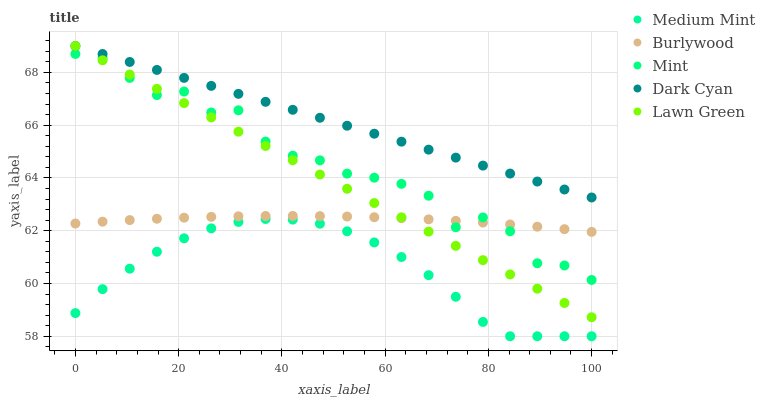Does Medium Mint have the minimum area under the curve?
Answer yes or no. Yes. Does Dark Cyan have the maximum area under the curve?
Answer yes or no. Yes. Does Burlywood have the minimum area under the curve?
Answer yes or no. No. Does Burlywood have the maximum area under the curve?
Answer yes or no. No. Is Lawn Green the smoothest?
Answer yes or no. Yes. Is Mint the roughest?
Answer yes or no. Yes. Is Burlywood the smoothest?
Answer yes or no. No. Is Burlywood the roughest?
Answer yes or no. No. Does Medium Mint have the lowest value?
Answer yes or no. Yes. Does Burlywood have the lowest value?
Answer yes or no. No. Does Lawn Green have the highest value?
Answer yes or no. Yes. Does Burlywood have the highest value?
Answer yes or no. No. Is Medium Mint less than Lawn Green?
Answer yes or no. Yes. Is Dark Cyan greater than Burlywood?
Answer yes or no. Yes. Does Burlywood intersect Mint?
Answer yes or no. Yes. Is Burlywood less than Mint?
Answer yes or no. No. Is Burlywood greater than Mint?
Answer yes or no. No. Does Medium Mint intersect Lawn Green?
Answer yes or no. No. 